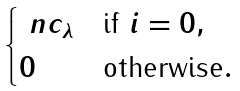Convert formula to latex. <formula><loc_0><loc_0><loc_500><loc_500>\begin{cases} \ n c _ { \lambda } & \text {if $i =0$} , \\ 0 & \text {otherwise} . \end{cases}</formula> 